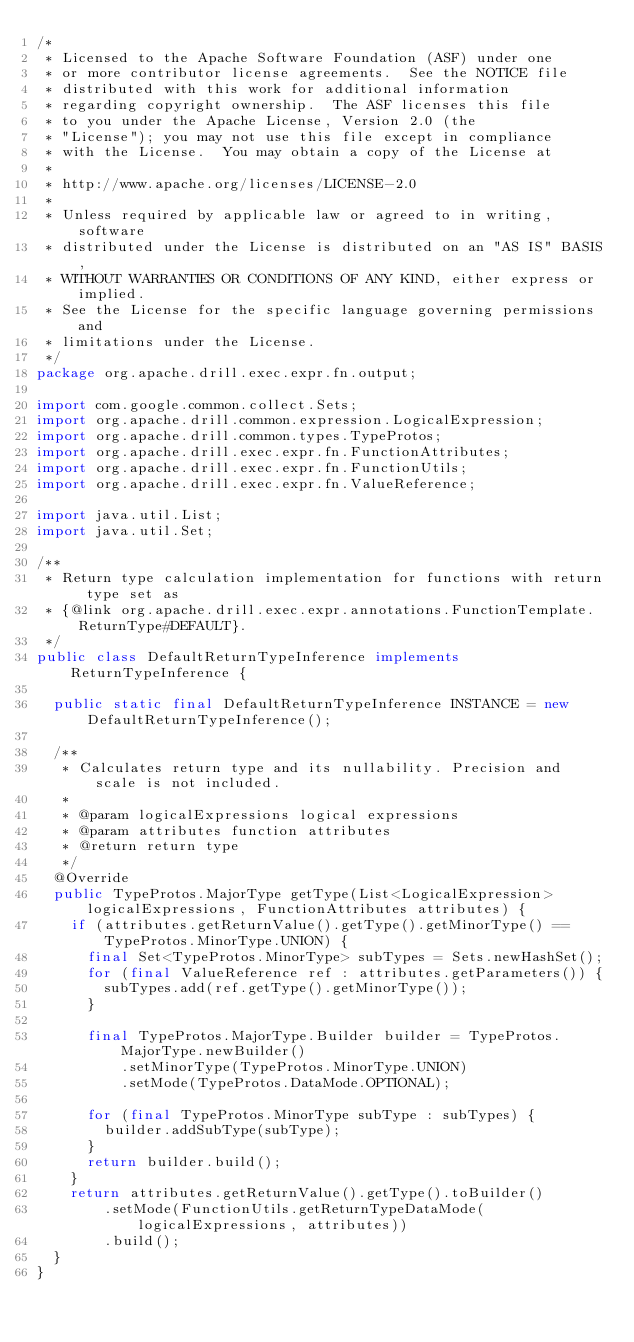Convert code to text. <code><loc_0><loc_0><loc_500><loc_500><_Java_>/*
 * Licensed to the Apache Software Foundation (ASF) under one
 * or more contributor license agreements.  See the NOTICE file
 * distributed with this work for additional information
 * regarding copyright ownership.  The ASF licenses this file
 * to you under the Apache License, Version 2.0 (the
 * "License"); you may not use this file except in compliance
 * with the License.  You may obtain a copy of the License at
 *
 * http://www.apache.org/licenses/LICENSE-2.0
 *
 * Unless required by applicable law or agreed to in writing, software
 * distributed under the License is distributed on an "AS IS" BASIS,
 * WITHOUT WARRANTIES OR CONDITIONS OF ANY KIND, either express or implied.
 * See the License for the specific language governing permissions and
 * limitations under the License.
 */
package org.apache.drill.exec.expr.fn.output;

import com.google.common.collect.Sets;
import org.apache.drill.common.expression.LogicalExpression;
import org.apache.drill.common.types.TypeProtos;
import org.apache.drill.exec.expr.fn.FunctionAttributes;
import org.apache.drill.exec.expr.fn.FunctionUtils;
import org.apache.drill.exec.expr.fn.ValueReference;

import java.util.List;
import java.util.Set;

/**
 * Return type calculation implementation for functions with return type set as
 * {@link org.apache.drill.exec.expr.annotations.FunctionTemplate.ReturnType#DEFAULT}.
 */
public class DefaultReturnTypeInference implements ReturnTypeInference {

  public static final DefaultReturnTypeInference INSTANCE = new DefaultReturnTypeInference();

  /**
   * Calculates return type and its nullability. Precision and scale is not included.
   *
   * @param logicalExpressions logical expressions
   * @param attributes function attributes
   * @return return type
   */
  @Override
  public TypeProtos.MajorType getType(List<LogicalExpression> logicalExpressions, FunctionAttributes attributes) {
    if (attributes.getReturnValue().getType().getMinorType() == TypeProtos.MinorType.UNION) {
      final Set<TypeProtos.MinorType> subTypes = Sets.newHashSet();
      for (final ValueReference ref : attributes.getParameters()) {
        subTypes.add(ref.getType().getMinorType());
      }

      final TypeProtos.MajorType.Builder builder = TypeProtos.MajorType.newBuilder()
          .setMinorType(TypeProtos.MinorType.UNION)
          .setMode(TypeProtos.DataMode.OPTIONAL);

      for (final TypeProtos.MinorType subType : subTypes) {
        builder.addSubType(subType);
      }
      return builder.build();
    }
    return attributes.getReturnValue().getType().toBuilder()
        .setMode(FunctionUtils.getReturnTypeDataMode(logicalExpressions, attributes))
        .build();
  }
}
</code> 